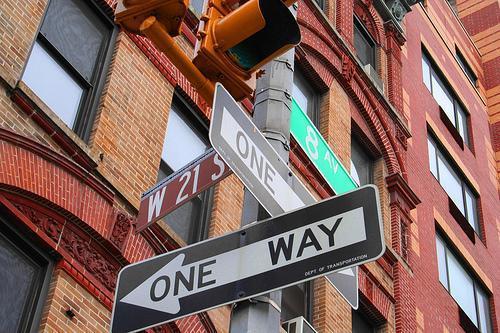How many signs are pictured?
Give a very brief answer. 4. How many one-way signs?
Give a very brief answer. 2. 